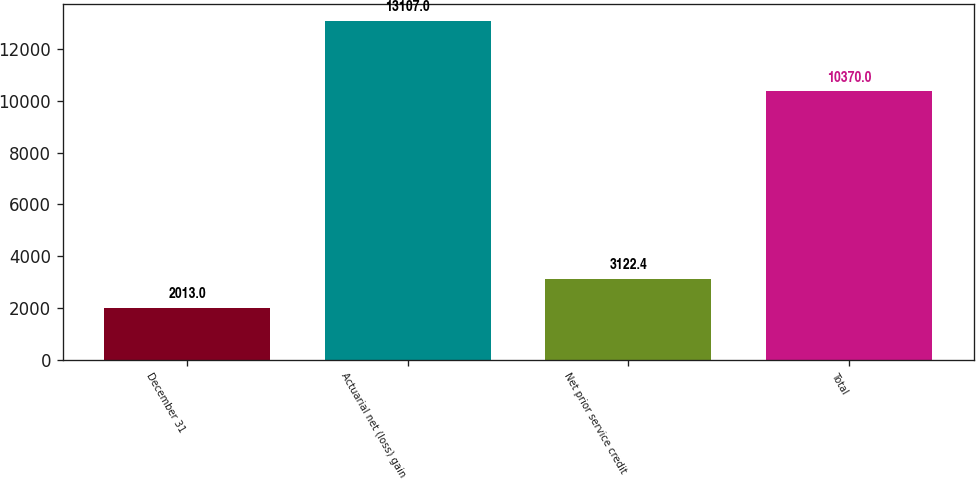Convert chart. <chart><loc_0><loc_0><loc_500><loc_500><bar_chart><fcel>December 31<fcel>Actuarial net (loss) gain<fcel>Net prior service credit<fcel>Total<nl><fcel>2013<fcel>13107<fcel>3122.4<fcel>10370<nl></chart> 